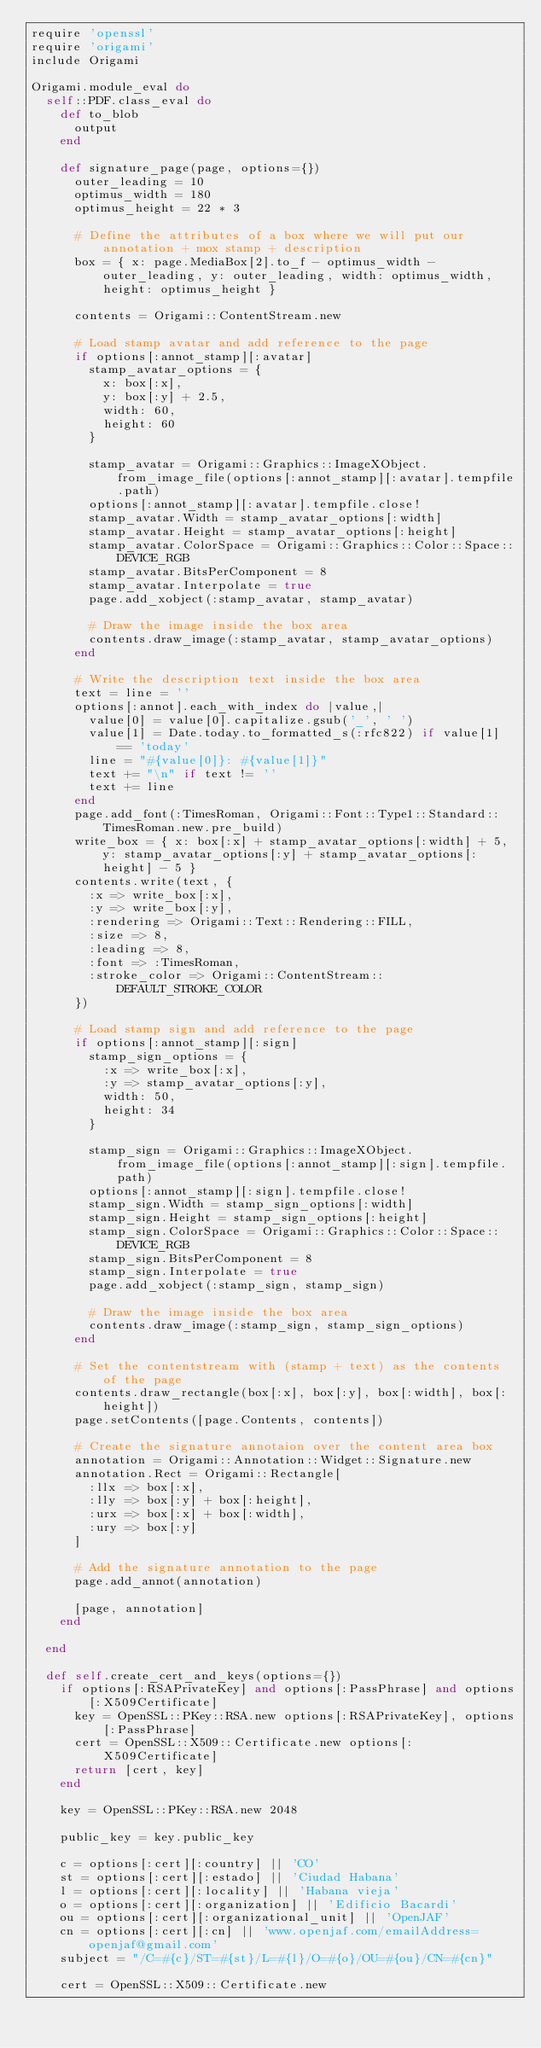<code> <loc_0><loc_0><loc_500><loc_500><_Ruby_>require 'openssl'
require 'origami'
include Origami

Origami.module_eval do
  self::PDF.class_eval do
    def to_blob
      output
    end

    def signature_page(page, options={})
      outer_leading = 10
      optimus_width = 180
      optimus_height = 22 * 3

      # Define the attributes of a box where we will put our annotation + mox stamp + description
      box = { x: page.MediaBox[2].to_f - optimus_width - outer_leading, y: outer_leading, width: optimus_width, height: optimus_height }

      contents = Origami::ContentStream.new

      # Load stamp avatar and add reference to the page
      if options[:annot_stamp][:avatar]
        stamp_avatar_options = {
          x: box[:x],
          y: box[:y] + 2.5,
          width: 60,
          height: 60
        }

        stamp_avatar = Origami::Graphics::ImageXObject.from_image_file(options[:annot_stamp][:avatar].tempfile.path)
        options[:annot_stamp][:avatar].tempfile.close!
        stamp_avatar.Width = stamp_avatar_options[:width]
        stamp_avatar.Height = stamp_avatar_options[:height]
        stamp_avatar.ColorSpace = Origami::Graphics::Color::Space::DEVICE_RGB
        stamp_avatar.BitsPerComponent = 8
        stamp_avatar.Interpolate = true
        page.add_xobject(:stamp_avatar, stamp_avatar)

        # Draw the image inside the box area
        contents.draw_image(:stamp_avatar, stamp_avatar_options)
      end

      # Write the description text inside the box area
      text = line = ''
      options[:annot].each_with_index do |value,|
        value[0] = value[0].capitalize.gsub('_', ' ')
        value[1] = Date.today.to_formatted_s(:rfc822) if value[1] == 'today'
        line = "#{value[0]}: #{value[1]}"
        text += "\n" if text != ''
        text += line
      end
      page.add_font(:TimesRoman, Origami::Font::Type1::Standard::TimesRoman.new.pre_build)
      write_box = { x: box[:x] + stamp_avatar_options[:width] + 5, y: stamp_avatar_options[:y] + stamp_avatar_options[:height] - 5 }
      contents.write(text, {
        :x => write_box[:x],
        :y => write_box[:y],
        :rendering => Origami::Text::Rendering::FILL,
        :size => 8,
        :leading => 8,
        :font => :TimesRoman,
        :stroke_color => Origami::ContentStream::DEFAULT_STROKE_COLOR
      })

      # Load stamp sign and add reference to the page
      if options[:annot_stamp][:sign]
        stamp_sign_options = {
          :x => write_box[:x],
          :y => stamp_avatar_options[:y],
          width: 50,
          height: 34
        }

        stamp_sign = Origami::Graphics::ImageXObject.from_image_file(options[:annot_stamp][:sign].tempfile.path)
        options[:annot_stamp][:sign].tempfile.close!
        stamp_sign.Width = stamp_sign_options[:width]
        stamp_sign.Height = stamp_sign_options[:height]
        stamp_sign.ColorSpace = Origami::Graphics::Color::Space::DEVICE_RGB
        stamp_sign.BitsPerComponent = 8
        stamp_sign.Interpolate = true
        page.add_xobject(:stamp_sign, stamp_sign)

        # Draw the image inside the box area
        contents.draw_image(:stamp_sign, stamp_sign_options)
      end

      # Set the contentstream with (stamp + text) as the contents of the page
      contents.draw_rectangle(box[:x], box[:y], box[:width], box[:height])
      page.setContents([page.Contents, contents])

      # Create the signature annotaion over the content area box
      annotation = Origami::Annotation::Widget::Signature.new
      annotation.Rect = Origami::Rectangle[
        :llx => box[:x],
        :lly => box[:y] + box[:height],
        :urx => box[:x] + box[:width],
        :ury => box[:y]
      ]

      # Add the signature annotation to the page
      page.add_annot(annotation)

      [page, annotation]
    end

  end

  def self.create_cert_and_keys(options={})
    if options[:RSAPrivateKey] and options[:PassPhrase] and options[:X509Certificate]
      key = OpenSSL::PKey::RSA.new options[:RSAPrivateKey], options[:PassPhrase]
      cert = OpenSSL::X509::Certificate.new options[:X509Certificate]
      return [cert, key]
    end

    key = OpenSSL::PKey::RSA.new 2048

    public_key = key.public_key

    c = options[:cert][:country] || 'CO'
    st = options[:cert][:estado] || 'Ciudad Habana'
    l = options[:cert][:locality] || 'Habana vieja'
    o = options[:cert][:organization] || 'Edificio Bacardi'
    ou = options[:cert][:organizational_unit] || 'OpenJAF'
    cn = options[:cert][:cn] || 'www.openjaf.com/emailAddress=openjaf@gmail.com'
    subject = "/C=#{c}/ST=#{st}/L=#{l}/O=#{o}/OU=#{ou}/CN=#{cn}"

    cert = OpenSSL::X509::Certificate.new</code> 